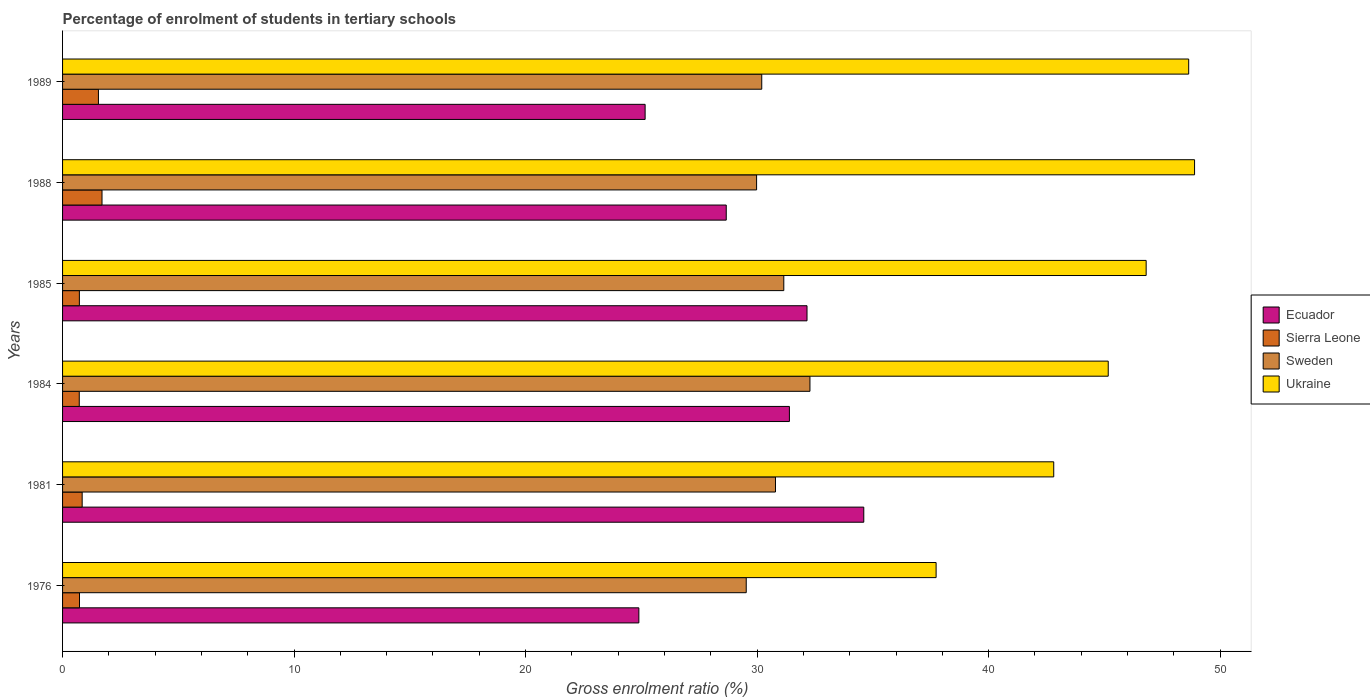How many different coloured bars are there?
Provide a succinct answer. 4. What is the label of the 3rd group of bars from the top?
Your answer should be compact. 1985. What is the percentage of students enrolled in tertiary schools in Sierra Leone in 1985?
Give a very brief answer. 0.73. Across all years, what is the maximum percentage of students enrolled in tertiary schools in Ecuador?
Your answer should be compact. 34.61. Across all years, what is the minimum percentage of students enrolled in tertiary schools in Ukraine?
Give a very brief answer. 37.73. In which year was the percentage of students enrolled in tertiary schools in Sierra Leone maximum?
Provide a succinct answer. 1988. In which year was the percentage of students enrolled in tertiary schools in Ukraine minimum?
Keep it short and to the point. 1976. What is the total percentage of students enrolled in tertiary schools in Ukraine in the graph?
Your answer should be very brief. 270.06. What is the difference between the percentage of students enrolled in tertiary schools in Ukraine in 1981 and that in 1988?
Your answer should be very brief. -6.08. What is the difference between the percentage of students enrolled in tertiary schools in Ukraine in 1985 and the percentage of students enrolled in tertiary schools in Sierra Leone in 1989?
Ensure brevity in your answer.  45.26. What is the average percentage of students enrolled in tertiary schools in Sweden per year?
Your answer should be compact. 30.66. In the year 1976, what is the difference between the percentage of students enrolled in tertiary schools in Ukraine and percentage of students enrolled in tertiary schools in Sierra Leone?
Ensure brevity in your answer.  37. In how many years, is the percentage of students enrolled in tertiary schools in Sierra Leone greater than 18 %?
Provide a succinct answer. 0. What is the ratio of the percentage of students enrolled in tertiary schools in Ukraine in 1976 to that in 1984?
Offer a very short reply. 0.84. What is the difference between the highest and the second highest percentage of students enrolled in tertiary schools in Ecuador?
Provide a short and direct response. 2.45. What is the difference between the highest and the lowest percentage of students enrolled in tertiary schools in Ukraine?
Provide a short and direct response. 11.16. In how many years, is the percentage of students enrolled in tertiary schools in Sierra Leone greater than the average percentage of students enrolled in tertiary schools in Sierra Leone taken over all years?
Provide a short and direct response. 2. Is the sum of the percentage of students enrolled in tertiary schools in Sierra Leone in 1981 and 1984 greater than the maximum percentage of students enrolled in tertiary schools in Sweden across all years?
Offer a very short reply. No. Is it the case that in every year, the sum of the percentage of students enrolled in tertiary schools in Ecuador and percentage of students enrolled in tertiary schools in Sweden is greater than the sum of percentage of students enrolled in tertiary schools in Ukraine and percentage of students enrolled in tertiary schools in Sierra Leone?
Offer a terse response. Yes. What does the 1st bar from the top in 1976 represents?
Offer a terse response. Ukraine. What does the 1st bar from the bottom in 1981 represents?
Ensure brevity in your answer.  Ecuador. How many bars are there?
Make the answer very short. 24. Are the values on the major ticks of X-axis written in scientific E-notation?
Provide a succinct answer. No. Does the graph contain grids?
Your answer should be compact. No. How many legend labels are there?
Provide a succinct answer. 4. What is the title of the graph?
Make the answer very short. Percentage of enrolment of students in tertiary schools. Does "Mauritania" appear as one of the legend labels in the graph?
Provide a short and direct response. No. What is the label or title of the Y-axis?
Offer a terse response. Years. What is the Gross enrolment ratio (%) of Ecuador in 1976?
Ensure brevity in your answer.  24.89. What is the Gross enrolment ratio (%) in Sierra Leone in 1976?
Give a very brief answer. 0.73. What is the Gross enrolment ratio (%) in Sweden in 1976?
Your answer should be very brief. 29.53. What is the Gross enrolment ratio (%) of Ukraine in 1976?
Keep it short and to the point. 37.73. What is the Gross enrolment ratio (%) in Ecuador in 1981?
Offer a very short reply. 34.61. What is the Gross enrolment ratio (%) of Sierra Leone in 1981?
Keep it short and to the point. 0.85. What is the Gross enrolment ratio (%) in Sweden in 1981?
Offer a very short reply. 30.79. What is the Gross enrolment ratio (%) of Ukraine in 1981?
Offer a terse response. 42.81. What is the Gross enrolment ratio (%) in Ecuador in 1984?
Ensure brevity in your answer.  31.4. What is the Gross enrolment ratio (%) of Sierra Leone in 1984?
Keep it short and to the point. 0.72. What is the Gross enrolment ratio (%) in Sweden in 1984?
Your response must be concise. 32.28. What is the Gross enrolment ratio (%) in Ukraine in 1984?
Your answer should be very brief. 45.17. What is the Gross enrolment ratio (%) in Ecuador in 1985?
Provide a short and direct response. 32.16. What is the Gross enrolment ratio (%) of Sierra Leone in 1985?
Provide a short and direct response. 0.73. What is the Gross enrolment ratio (%) in Sweden in 1985?
Your response must be concise. 31.15. What is the Gross enrolment ratio (%) of Ukraine in 1985?
Make the answer very short. 46.8. What is the Gross enrolment ratio (%) in Ecuador in 1988?
Keep it short and to the point. 28.67. What is the Gross enrolment ratio (%) in Sierra Leone in 1988?
Provide a short and direct response. 1.7. What is the Gross enrolment ratio (%) of Sweden in 1988?
Offer a terse response. 29.98. What is the Gross enrolment ratio (%) of Ukraine in 1988?
Provide a short and direct response. 48.9. What is the Gross enrolment ratio (%) of Ecuador in 1989?
Offer a very short reply. 25.16. What is the Gross enrolment ratio (%) of Sierra Leone in 1989?
Your answer should be very brief. 1.55. What is the Gross enrolment ratio (%) in Sweden in 1989?
Your response must be concise. 30.2. What is the Gross enrolment ratio (%) of Ukraine in 1989?
Offer a terse response. 48.64. Across all years, what is the maximum Gross enrolment ratio (%) of Ecuador?
Provide a short and direct response. 34.61. Across all years, what is the maximum Gross enrolment ratio (%) of Sierra Leone?
Your answer should be very brief. 1.7. Across all years, what is the maximum Gross enrolment ratio (%) of Sweden?
Provide a succinct answer. 32.28. Across all years, what is the maximum Gross enrolment ratio (%) in Ukraine?
Your response must be concise. 48.9. Across all years, what is the minimum Gross enrolment ratio (%) in Ecuador?
Your answer should be compact. 24.89. Across all years, what is the minimum Gross enrolment ratio (%) in Sierra Leone?
Make the answer very short. 0.72. Across all years, what is the minimum Gross enrolment ratio (%) of Sweden?
Your answer should be very brief. 29.53. Across all years, what is the minimum Gross enrolment ratio (%) in Ukraine?
Make the answer very short. 37.73. What is the total Gross enrolment ratio (%) in Ecuador in the graph?
Your response must be concise. 176.88. What is the total Gross enrolment ratio (%) of Sierra Leone in the graph?
Offer a very short reply. 6.28. What is the total Gross enrolment ratio (%) of Sweden in the graph?
Your response must be concise. 183.94. What is the total Gross enrolment ratio (%) in Ukraine in the graph?
Your response must be concise. 270.06. What is the difference between the Gross enrolment ratio (%) of Ecuador in 1976 and that in 1981?
Provide a short and direct response. -9.72. What is the difference between the Gross enrolment ratio (%) in Sierra Leone in 1976 and that in 1981?
Make the answer very short. -0.12. What is the difference between the Gross enrolment ratio (%) of Sweden in 1976 and that in 1981?
Keep it short and to the point. -1.26. What is the difference between the Gross enrolment ratio (%) of Ukraine in 1976 and that in 1981?
Ensure brevity in your answer.  -5.08. What is the difference between the Gross enrolment ratio (%) in Ecuador in 1976 and that in 1984?
Your answer should be very brief. -6.5. What is the difference between the Gross enrolment ratio (%) of Sierra Leone in 1976 and that in 1984?
Provide a succinct answer. 0.01. What is the difference between the Gross enrolment ratio (%) in Sweden in 1976 and that in 1984?
Give a very brief answer. -2.75. What is the difference between the Gross enrolment ratio (%) in Ukraine in 1976 and that in 1984?
Give a very brief answer. -7.43. What is the difference between the Gross enrolment ratio (%) of Ecuador in 1976 and that in 1985?
Keep it short and to the point. -7.26. What is the difference between the Gross enrolment ratio (%) in Sierra Leone in 1976 and that in 1985?
Keep it short and to the point. 0.01. What is the difference between the Gross enrolment ratio (%) in Sweden in 1976 and that in 1985?
Provide a succinct answer. -1.62. What is the difference between the Gross enrolment ratio (%) of Ukraine in 1976 and that in 1985?
Your answer should be compact. -9.07. What is the difference between the Gross enrolment ratio (%) of Ecuador in 1976 and that in 1988?
Offer a very short reply. -3.77. What is the difference between the Gross enrolment ratio (%) of Sierra Leone in 1976 and that in 1988?
Give a very brief answer. -0.97. What is the difference between the Gross enrolment ratio (%) in Sweden in 1976 and that in 1988?
Your response must be concise. -0.45. What is the difference between the Gross enrolment ratio (%) of Ukraine in 1976 and that in 1988?
Your response must be concise. -11.16. What is the difference between the Gross enrolment ratio (%) of Ecuador in 1976 and that in 1989?
Ensure brevity in your answer.  -0.27. What is the difference between the Gross enrolment ratio (%) of Sierra Leone in 1976 and that in 1989?
Make the answer very short. -0.82. What is the difference between the Gross enrolment ratio (%) of Sweden in 1976 and that in 1989?
Your answer should be compact. -0.67. What is the difference between the Gross enrolment ratio (%) in Ukraine in 1976 and that in 1989?
Offer a terse response. -10.91. What is the difference between the Gross enrolment ratio (%) of Ecuador in 1981 and that in 1984?
Offer a very short reply. 3.21. What is the difference between the Gross enrolment ratio (%) of Sierra Leone in 1981 and that in 1984?
Give a very brief answer. 0.13. What is the difference between the Gross enrolment ratio (%) in Sweden in 1981 and that in 1984?
Offer a very short reply. -1.49. What is the difference between the Gross enrolment ratio (%) in Ukraine in 1981 and that in 1984?
Provide a succinct answer. -2.35. What is the difference between the Gross enrolment ratio (%) of Ecuador in 1981 and that in 1985?
Your response must be concise. 2.45. What is the difference between the Gross enrolment ratio (%) of Sierra Leone in 1981 and that in 1985?
Offer a very short reply. 0.12. What is the difference between the Gross enrolment ratio (%) in Sweden in 1981 and that in 1985?
Keep it short and to the point. -0.36. What is the difference between the Gross enrolment ratio (%) in Ukraine in 1981 and that in 1985?
Ensure brevity in your answer.  -3.99. What is the difference between the Gross enrolment ratio (%) in Ecuador in 1981 and that in 1988?
Offer a terse response. 5.94. What is the difference between the Gross enrolment ratio (%) in Sierra Leone in 1981 and that in 1988?
Ensure brevity in your answer.  -0.86. What is the difference between the Gross enrolment ratio (%) in Sweden in 1981 and that in 1988?
Your answer should be compact. 0.82. What is the difference between the Gross enrolment ratio (%) in Ukraine in 1981 and that in 1988?
Provide a succinct answer. -6.08. What is the difference between the Gross enrolment ratio (%) in Ecuador in 1981 and that in 1989?
Your answer should be compact. 9.45. What is the difference between the Gross enrolment ratio (%) in Sierra Leone in 1981 and that in 1989?
Offer a very short reply. -0.7. What is the difference between the Gross enrolment ratio (%) in Sweden in 1981 and that in 1989?
Your answer should be very brief. 0.59. What is the difference between the Gross enrolment ratio (%) of Ukraine in 1981 and that in 1989?
Offer a terse response. -5.83. What is the difference between the Gross enrolment ratio (%) in Ecuador in 1984 and that in 1985?
Your response must be concise. -0.76. What is the difference between the Gross enrolment ratio (%) of Sierra Leone in 1984 and that in 1985?
Provide a short and direct response. -0. What is the difference between the Gross enrolment ratio (%) of Sweden in 1984 and that in 1985?
Offer a terse response. 1.13. What is the difference between the Gross enrolment ratio (%) of Ukraine in 1984 and that in 1985?
Make the answer very short. -1.64. What is the difference between the Gross enrolment ratio (%) in Ecuador in 1984 and that in 1988?
Offer a terse response. 2.73. What is the difference between the Gross enrolment ratio (%) in Sierra Leone in 1984 and that in 1988?
Your response must be concise. -0.98. What is the difference between the Gross enrolment ratio (%) of Sweden in 1984 and that in 1988?
Provide a succinct answer. 2.3. What is the difference between the Gross enrolment ratio (%) in Ukraine in 1984 and that in 1988?
Give a very brief answer. -3.73. What is the difference between the Gross enrolment ratio (%) in Ecuador in 1984 and that in 1989?
Provide a succinct answer. 6.23. What is the difference between the Gross enrolment ratio (%) of Sierra Leone in 1984 and that in 1989?
Your answer should be very brief. -0.83. What is the difference between the Gross enrolment ratio (%) in Sweden in 1984 and that in 1989?
Keep it short and to the point. 2.08. What is the difference between the Gross enrolment ratio (%) in Ukraine in 1984 and that in 1989?
Provide a succinct answer. -3.48. What is the difference between the Gross enrolment ratio (%) in Ecuador in 1985 and that in 1988?
Provide a succinct answer. 3.49. What is the difference between the Gross enrolment ratio (%) of Sierra Leone in 1985 and that in 1988?
Keep it short and to the point. -0.98. What is the difference between the Gross enrolment ratio (%) in Sweden in 1985 and that in 1988?
Make the answer very short. 1.18. What is the difference between the Gross enrolment ratio (%) in Ukraine in 1985 and that in 1988?
Provide a short and direct response. -2.09. What is the difference between the Gross enrolment ratio (%) in Ecuador in 1985 and that in 1989?
Ensure brevity in your answer.  6.99. What is the difference between the Gross enrolment ratio (%) in Sierra Leone in 1985 and that in 1989?
Keep it short and to the point. -0.82. What is the difference between the Gross enrolment ratio (%) in Sweden in 1985 and that in 1989?
Offer a very short reply. 0.95. What is the difference between the Gross enrolment ratio (%) in Ukraine in 1985 and that in 1989?
Your response must be concise. -1.84. What is the difference between the Gross enrolment ratio (%) of Ecuador in 1988 and that in 1989?
Give a very brief answer. 3.5. What is the difference between the Gross enrolment ratio (%) in Sierra Leone in 1988 and that in 1989?
Give a very brief answer. 0.15. What is the difference between the Gross enrolment ratio (%) of Sweden in 1988 and that in 1989?
Give a very brief answer. -0.22. What is the difference between the Gross enrolment ratio (%) in Ukraine in 1988 and that in 1989?
Ensure brevity in your answer.  0.25. What is the difference between the Gross enrolment ratio (%) of Ecuador in 1976 and the Gross enrolment ratio (%) of Sierra Leone in 1981?
Give a very brief answer. 24.05. What is the difference between the Gross enrolment ratio (%) of Ecuador in 1976 and the Gross enrolment ratio (%) of Sweden in 1981?
Your answer should be compact. -5.9. What is the difference between the Gross enrolment ratio (%) of Ecuador in 1976 and the Gross enrolment ratio (%) of Ukraine in 1981?
Keep it short and to the point. -17.92. What is the difference between the Gross enrolment ratio (%) of Sierra Leone in 1976 and the Gross enrolment ratio (%) of Sweden in 1981?
Your answer should be very brief. -30.06. What is the difference between the Gross enrolment ratio (%) in Sierra Leone in 1976 and the Gross enrolment ratio (%) in Ukraine in 1981?
Ensure brevity in your answer.  -42.08. What is the difference between the Gross enrolment ratio (%) of Sweden in 1976 and the Gross enrolment ratio (%) of Ukraine in 1981?
Provide a succinct answer. -13.28. What is the difference between the Gross enrolment ratio (%) in Ecuador in 1976 and the Gross enrolment ratio (%) in Sierra Leone in 1984?
Your response must be concise. 24.17. What is the difference between the Gross enrolment ratio (%) in Ecuador in 1976 and the Gross enrolment ratio (%) in Sweden in 1984?
Keep it short and to the point. -7.39. What is the difference between the Gross enrolment ratio (%) of Ecuador in 1976 and the Gross enrolment ratio (%) of Ukraine in 1984?
Your answer should be compact. -20.27. What is the difference between the Gross enrolment ratio (%) in Sierra Leone in 1976 and the Gross enrolment ratio (%) in Sweden in 1984?
Provide a succinct answer. -31.55. What is the difference between the Gross enrolment ratio (%) in Sierra Leone in 1976 and the Gross enrolment ratio (%) in Ukraine in 1984?
Your answer should be compact. -44.44. What is the difference between the Gross enrolment ratio (%) of Sweden in 1976 and the Gross enrolment ratio (%) of Ukraine in 1984?
Your answer should be compact. -15.64. What is the difference between the Gross enrolment ratio (%) of Ecuador in 1976 and the Gross enrolment ratio (%) of Sierra Leone in 1985?
Provide a short and direct response. 24.17. What is the difference between the Gross enrolment ratio (%) of Ecuador in 1976 and the Gross enrolment ratio (%) of Sweden in 1985?
Provide a succinct answer. -6.26. What is the difference between the Gross enrolment ratio (%) in Ecuador in 1976 and the Gross enrolment ratio (%) in Ukraine in 1985?
Your response must be concise. -21.91. What is the difference between the Gross enrolment ratio (%) in Sierra Leone in 1976 and the Gross enrolment ratio (%) in Sweden in 1985?
Provide a short and direct response. -30.42. What is the difference between the Gross enrolment ratio (%) of Sierra Leone in 1976 and the Gross enrolment ratio (%) of Ukraine in 1985?
Keep it short and to the point. -46.07. What is the difference between the Gross enrolment ratio (%) of Sweden in 1976 and the Gross enrolment ratio (%) of Ukraine in 1985?
Provide a succinct answer. -17.27. What is the difference between the Gross enrolment ratio (%) of Ecuador in 1976 and the Gross enrolment ratio (%) of Sierra Leone in 1988?
Make the answer very short. 23.19. What is the difference between the Gross enrolment ratio (%) of Ecuador in 1976 and the Gross enrolment ratio (%) of Sweden in 1988?
Your answer should be compact. -5.09. What is the difference between the Gross enrolment ratio (%) in Ecuador in 1976 and the Gross enrolment ratio (%) in Ukraine in 1988?
Offer a very short reply. -24. What is the difference between the Gross enrolment ratio (%) of Sierra Leone in 1976 and the Gross enrolment ratio (%) of Sweden in 1988?
Keep it short and to the point. -29.25. What is the difference between the Gross enrolment ratio (%) in Sierra Leone in 1976 and the Gross enrolment ratio (%) in Ukraine in 1988?
Ensure brevity in your answer.  -48.16. What is the difference between the Gross enrolment ratio (%) of Sweden in 1976 and the Gross enrolment ratio (%) of Ukraine in 1988?
Give a very brief answer. -19.37. What is the difference between the Gross enrolment ratio (%) in Ecuador in 1976 and the Gross enrolment ratio (%) in Sierra Leone in 1989?
Give a very brief answer. 23.34. What is the difference between the Gross enrolment ratio (%) of Ecuador in 1976 and the Gross enrolment ratio (%) of Sweden in 1989?
Your answer should be compact. -5.31. What is the difference between the Gross enrolment ratio (%) in Ecuador in 1976 and the Gross enrolment ratio (%) in Ukraine in 1989?
Keep it short and to the point. -23.75. What is the difference between the Gross enrolment ratio (%) in Sierra Leone in 1976 and the Gross enrolment ratio (%) in Sweden in 1989?
Provide a succinct answer. -29.47. What is the difference between the Gross enrolment ratio (%) in Sierra Leone in 1976 and the Gross enrolment ratio (%) in Ukraine in 1989?
Offer a terse response. -47.91. What is the difference between the Gross enrolment ratio (%) of Sweden in 1976 and the Gross enrolment ratio (%) of Ukraine in 1989?
Your answer should be very brief. -19.11. What is the difference between the Gross enrolment ratio (%) of Ecuador in 1981 and the Gross enrolment ratio (%) of Sierra Leone in 1984?
Your answer should be compact. 33.89. What is the difference between the Gross enrolment ratio (%) of Ecuador in 1981 and the Gross enrolment ratio (%) of Sweden in 1984?
Your answer should be very brief. 2.33. What is the difference between the Gross enrolment ratio (%) in Ecuador in 1981 and the Gross enrolment ratio (%) in Ukraine in 1984?
Your answer should be compact. -10.56. What is the difference between the Gross enrolment ratio (%) of Sierra Leone in 1981 and the Gross enrolment ratio (%) of Sweden in 1984?
Keep it short and to the point. -31.44. What is the difference between the Gross enrolment ratio (%) of Sierra Leone in 1981 and the Gross enrolment ratio (%) of Ukraine in 1984?
Give a very brief answer. -44.32. What is the difference between the Gross enrolment ratio (%) of Sweden in 1981 and the Gross enrolment ratio (%) of Ukraine in 1984?
Make the answer very short. -14.37. What is the difference between the Gross enrolment ratio (%) in Ecuador in 1981 and the Gross enrolment ratio (%) in Sierra Leone in 1985?
Your response must be concise. 33.88. What is the difference between the Gross enrolment ratio (%) of Ecuador in 1981 and the Gross enrolment ratio (%) of Sweden in 1985?
Keep it short and to the point. 3.45. What is the difference between the Gross enrolment ratio (%) of Ecuador in 1981 and the Gross enrolment ratio (%) of Ukraine in 1985?
Offer a terse response. -12.2. What is the difference between the Gross enrolment ratio (%) of Sierra Leone in 1981 and the Gross enrolment ratio (%) of Sweden in 1985?
Make the answer very short. -30.31. What is the difference between the Gross enrolment ratio (%) of Sierra Leone in 1981 and the Gross enrolment ratio (%) of Ukraine in 1985?
Your answer should be very brief. -45.96. What is the difference between the Gross enrolment ratio (%) of Sweden in 1981 and the Gross enrolment ratio (%) of Ukraine in 1985?
Your answer should be very brief. -16.01. What is the difference between the Gross enrolment ratio (%) of Ecuador in 1981 and the Gross enrolment ratio (%) of Sierra Leone in 1988?
Offer a very short reply. 32.9. What is the difference between the Gross enrolment ratio (%) of Ecuador in 1981 and the Gross enrolment ratio (%) of Sweden in 1988?
Offer a very short reply. 4.63. What is the difference between the Gross enrolment ratio (%) in Ecuador in 1981 and the Gross enrolment ratio (%) in Ukraine in 1988?
Provide a succinct answer. -14.29. What is the difference between the Gross enrolment ratio (%) in Sierra Leone in 1981 and the Gross enrolment ratio (%) in Sweden in 1988?
Offer a terse response. -29.13. What is the difference between the Gross enrolment ratio (%) in Sierra Leone in 1981 and the Gross enrolment ratio (%) in Ukraine in 1988?
Ensure brevity in your answer.  -48.05. What is the difference between the Gross enrolment ratio (%) of Sweden in 1981 and the Gross enrolment ratio (%) of Ukraine in 1988?
Give a very brief answer. -18.1. What is the difference between the Gross enrolment ratio (%) of Ecuador in 1981 and the Gross enrolment ratio (%) of Sierra Leone in 1989?
Keep it short and to the point. 33.06. What is the difference between the Gross enrolment ratio (%) of Ecuador in 1981 and the Gross enrolment ratio (%) of Sweden in 1989?
Provide a short and direct response. 4.41. What is the difference between the Gross enrolment ratio (%) of Ecuador in 1981 and the Gross enrolment ratio (%) of Ukraine in 1989?
Your answer should be very brief. -14.03. What is the difference between the Gross enrolment ratio (%) of Sierra Leone in 1981 and the Gross enrolment ratio (%) of Sweden in 1989?
Ensure brevity in your answer.  -29.35. What is the difference between the Gross enrolment ratio (%) in Sierra Leone in 1981 and the Gross enrolment ratio (%) in Ukraine in 1989?
Keep it short and to the point. -47.8. What is the difference between the Gross enrolment ratio (%) in Sweden in 1981 and the Gross enrolment ratio (%) in Ukraine in 1989?
Offer a terse response. -17.85. What is the difference between the Gross enrolment ratio (%) of Ecuador in 1984 and the Gross enrolment ratio (%) of Sierra Leone in 1985?
Offer a terse response. 30.67. What is the difference between the Gross enrolment ratio (%) of Ecuador in 1984 and the Gross enrolment ratio (%) of Sweden in 1985?
Give a very brief answer. 0.24. What is the difference between the Gross enrolment ratio (%) in Ecuador in 1984 and the Gross enrolment ratio (%) in Ukraine in 1985?
Ensure brevity in your answer.  -15.41. What is the difference between the Gross enrolment ratio (%) in Sierra Leone in 1984 and the Gross enrolment ratio (%) in Sweden in 1985?
Your answer should be very brief. -30.43. What is the difference between the Gross enrolment ratio (%) of Sierra Leone in 1984 and the Gross enrolment ratio (%) of Ukraine in 1985?
Your response must be concise. -46.08. What is the difference between the Gross enrolment ratio (%) in Sweden in 1984 and the Gross enrolment ratio (%) in Ukraine in 1985?
Give a very brief answer. -14.52. What is the difference between the Gross enrolment ratio (%) of Ecuador in 1984 and the Gross enrolment ratio (%) of Sierra Leone in 1988?
Your answer should be very brief. 29.69. What is the difference between the Gross enrolment ratio (%) of Ecuador in 1984 and the Gross enrolment ratio (%) of Sweden in 1988?
Make the answer very short. 1.42. What is the difference between the Gross enrolment ratio (%) in Ecuador in 1984 and the Gross enrolment ratio (%) in Ukraine in 1988?
Provide a succinct answer. -17.5. What is the difference between the Gross enrolment ratio (%) of Sierra Leone in 1984 and the Gross enrolment ratio (%) of Sweden in 1988?
Offer a very short reply. -29.26. What is the difference between the Gross enrolment ratio (%) in Sierra Leone in 1984 and the Gross enrolment ratio (%) in Ukraine in 1988?
Your response must be concise. -48.17. What is the difference between the Gross enrolment ratio (%) in Sweden in 1984 and the Gross enrolment ratio (%) in Ukraine in 1988?
Give a very brief answer. -16.61. What is the difference between the Gross enrolment ratio (%) of Ecuador in 1984 and the Gross enrolment ratio (%) of Sierra Leone in 1989?
Your answer should be very brief. 29.85. What is the difference between the Gross enrolment ratio (%) in Ecuador in 1984 and the Gross enrolment ratio (%) in Sweden in 1989?
Make the answer very short. 1.19. What is the difference between the Gross enrolment ratio (%) of Ecuador in 1984 and the Gross enrolment ratio (%) of Ukraine in 1989?
Make the answer very short. -17.25. What is the difference between the Gross enrolment ratio (%) in Sierra Leone in 1984 and the Gross enrolment ratio (%) in Sweden in 1989?
Offer a very short reply. -29.48. What is the difference between the Gross enrolment ratio (%) of Sierra Leone in 1984 and the Gross enrolment ratio (%) of Ukraine in 1989?
Ensure brevity in your answer.  -47.92. What is the difference between the Gross enrolment ratio (%) of Sweden in 1984 and the Gross enrolment ratio (%) of Ukraine in 1989?
Your response must be concise. -16.36. What is the difference between the Gross enrolment ratio (%) in Ecuador in 1985 and the Gross enrolment ratio (%) in Sierra Leone in 1988?
Provide a short and direct response. 30.45. What is the difference between the Gross enrolment ratio (%) of Ecuador in 1985 and the Gross enrolment ratio (%) of Sweden in 1988?
Offer a terse response. 2.18. What is the difference between the Gross enrolment ratio (%) in Ecuador in 1985 and the Gross enrolment ratio (%) in Ukraine in 1988?
Offer a very short reply. -16.74. What is the difference between the Gross enrolment ratio (%) in Sierra Leone in 1985 and the Gross enrolment ratio (%) in Sweden in 1988?
Provide a short and direct response. -29.25. What is the difference between the Gross enrolment ratio (%) of Sierra Leone in 1985 and the Gross enrolment ratio (%) of Ukraine in 1988?
Your answer should be compact. -48.17. What is the difference between the Gross enrolment ratio (%) of Sweden in 1985 and the Gross enrolment ratio (%) of Ukraine in 1988?
Your answer should be very brief. -17.74. What is the difference between the Gross enrolment ratio (%) of Ecuador in 1985 and the Gross enrolment ratio (%) of Sierra Leone in 1989?
Your answer should be compact. 30.61. What is the difference between the Gross enrolment ratio (%) of Ecuador in 1985 and the Gross enrolment ratio (%) of Sweden in 1989?
Your answer should be compact. 1.96. What is the difference between the Gross enrolment ratio (%) of Ecuador in 1985 and the Gross enrolment ratio (%) of Ukraine in 1989?
Ensure brevity in your answer.  -16.49. What is the difference between the Gross enrolment ratio (%) of Sierra Leone in 1985 and the Gross enrolment ratio (%) of Sweden in 1989?
Offer a very short reply. -29.47. What is the difference between the Gross enrolment ratio (%) in Sierra Leone in 1985 and the Gross enrolment ratio (%) in Ukraine in 1989?
Give a very brief answer. -47.92. What is the difference between the Gross enrolment ratio (%) of Sweden in 1985 and the Gross enrolment ratio (%) of Ukraine in 1989?
Provide a short and direct response. -17.49. What is the difference between the Gross enrolment ratio (%) in Ecuador in 1988 and the Gross enrolment ratio (%) in Sierra Leone in 1989?
Give a very brief answer. 27.12. What is the difference between the Gross enrolment ratio (%) of Ecuador in 1988 and the Gross enrolment ratio (%) of Sweden in 1989?
Your response must be concise. -1.53. What is the difference between the Gross enrolment ratio (%) in Ecuador in 1988 and the Gross enrolment ratio (%) in Ukraine in 1989?
Ensure brevity in your answer.  -19.97. What is the difference between the Gross enrolment ratio (%) of Sierra Leone in 1988 and the Gross enrolment ratio (%) of Sweden in 1989?
Keep it short and to the point. -28.5. What is the difference between the Gross enrolment ratio (%) of Sierra Leone in 1988 and the Gross enrolment ratio (%) of Ukraine in 1989?
Ensure brevity in your answer.  -46.94. What is the difference between the Gross enrolment ratio (%) in Sweden in 1988 and the Gross enrolment ratio (%) in Ukraine in 1989?
Ensure brevity in your answer.  -18.66. What is the average Gross enrolment ratio (%) of Ecuador per year?
Offer a very short reply. 29.48. What is the average Gross enrolment ratio (%) of Sierra Leone per year?
Your answer should be very brief. 1.05. What is the average Gross enrolment ratio (%) in Sweden per year?
Keep it short and to the point. 30.66. What is the average Gross enrolment ratio (%) in Ukraine per year?
Provide a succinct answer. 45.01. In the year 1976, what is the difference between the Gross enrolment ratio (%) of Ecuador and Gross enrolment ratio (%) of Sierra Leone?
Provide a short and direct response. 24.16. In the year 1976, what is the difference between the Gross enrolment ratio (%) of Ecuador and Gross enrolment ratio (%) of Sweden?
Offer a very short reply. -4.64. In the year 1976, what is the difference between the Gross enrolment ratio (%) in Ecuador and Gross enrolment ratio (%) in Ukraine?
Give a very brief answer. -12.84. In the year 1976, what is the difference between the Gross enrolment ratio (%) in Sierra Leone and Gross enrolment ratio (%) in Sweden?
Offer a very short reply. -28.8. In the year 1976, what is the difference between the Gross enrolment ratio (%) of Sierra Leone and Gross enrolment ratio (%) of Ukraine?
Ensure brevity in your answer.  -37. In the year 1976, what is the difference between the Gross enrolment ratio (%) in Sweden and Gross enrolment ratio (%) in Ukraine?
Keep it short and to the point. -8.2. In the year 1981, what is the difference between the Gross enrolment ratio (%) in Ecuador and Gross enrolment ratio (%) in Sierra Leone?
Keep it short and to the point. 33.76. In the year 1981, what is the difference between the Gross enrolment ratio (%) in Ecuador and Gross enrolment ratio (%) in Sweden?
Provide a succinct answer. 3.81. In the year 1981, what is the difference between the Gross enrolment ratio (%) in Ecuador and Gross enrolment ratio (%) in Ukraine?
Your answer should be very brief. -8.2. In the year 1981, what is the difference between the Gross enrolment ratio (%) in Sierra Leone and Gross enrolment ratio (%) in Sweden?
Provide a succinct answer. -29.95. In the year 1981, what is the difference between the Gross enrolment ratio (%) in Sierra Leone and Gross enrolment ratio (%) in Ukraine?
Your answer should be compact. -41.97. In the year 1981, what is the difference between the Gross enrolment ratio (%) in Sweden and Gross enrolment ratio (%) in Ukraine?
Provide a succinct answer. -12.02. In the year 1984, what is the difference between the Gross enrolment ratio (%) of Ecuador and Gross enrolment ratio (%) of Sierra Leone?
Ensure brevity in your answer.  30.67. In the year 1984, what is the difference between the Gross enrolment ratio (%) in Ecuador and Gross enrolment ratio (%) in Sweden?
Your response must be concise. -0.89. In the year 1984, what is the difference between the Gross enrolment ratio (%) in Ecuador and Gross enrolment ratio (%) in Ukraine?
Ensure brevity in your answer.  -13.77. In the year 1984, what is the difference between the Gross enrolment ratio (%) of Sierra Leone and Gross enrolment ratio (%) of Sweden?
Make the answer very short. -31.56. In the year 1984, what is the difference between the Gross enrolment ratio (%) of Sierra Leone and Gross enrolment ratio (%) of Ukraine?
Provide a short and direct response. -44.45. In the year 1984, what is the difference between the Gross enrolment ratio (%) of Sweden and Gross enrolment ratio (%) of Ukraine?
Offer a very short reply. -12.88. In the year 1985, what is the difference between the Gross enrolment ratio (%) of Ecuador and Gross enrolment ratio (%) of Sierra Leone?
Give a very brief answer. 31.43. In the year 1985, what is the difference between the Gross enrolment ratio (%) of Ecuador and Gross enrolment ratio (%) of Sweden?
Provide a succinct answer. 1. In the year 1985, what is the difference between the Gross enrolment ratio (%) in Ecuador and Gross enrolment ratio (%) in Ukraine?
Make the answer very short. -14.65. In the year 1985, what is the difference between the Gross enrolment ratio (%) in Sierra Leone and Gross enrolment ratio (%) in Sweden?
Make the answer very short. -30.43. In the year 1985, what is the difference between the Gross enrolment ratio (%) in Sierra Leone and Gross enrolment ratio (%) in Ukraine?
Ensure brevity in your answer.  -46.08. In the year 1985, what is the difference between the Gross enrolment ratio (%) of Sweden and Gross enrolment ratio (%) of Ukraine?
Keep it short and to the point. -15.65. In the year 1988, what is the difference between the Gross enrolment ratio (%) in Ecuador and Gross enrolment ratio (%) in Sierra Leone?
Keep it short and to the point. 26.96. In the year 1988, what is the difference between the Gross enrolment ratio (%) of Ecuador and Gross enrolment ratio (%) of Sweden?
Ensure brevity in your answer.  -1.31. In the year 1988, what is the difference between the Gross enrolment ratio (%) in Ecuador and Gross enrolment ratio (%) in Ukraine?
Make the answer very short. -20.23. In the year 1988, what is the difference between the Gross enrolment ratio (%) of Sierra Leone and Gross enrolment ratio (%) of Sweden?
Your answer should be very brief. -28.27. In the year 1988, what is the difference between the Gross enrolment ratio (%) of Sierra Leone and Gross enrolment ratio (%) of Ukraine?
Your response must be concise. -47.19. In the year 1988, what is the difference between the Gross enrolment ratio (%) of Sweden and Gross enrolment ratio (%) of Ukraine?
Make the answer very short. -18.92. In the year 1989, what is the difference between the Gross enrolment ratio (%) of Ecuador and Gross enrolment ratio (%) of Sierra Leone?
Provide a short and direct response. 23.61. In the year 1989, what is the difference between the Gross enrolment ratio (%) of Ecuador and Gross enrolment ratio (%) of Sweden?
Ensure brevity in your answer.  -5.04. In the year 1989, what is the difference between the Gross enrolment ratio (%) of Ecuador and Gross enrolment ratio (%) of Ukraine?
Give a very brief answer. -23.48. In the year 1989, what is the difference between the Gross enrolment ratio (%) of Sierra Leone and Gross enrolment ratio (%) of Sweden?
Ensure brevity in your answer.  -28.65. In the year 1989, what is the difference between the Gross enrolment ratio (%) in Sierra Leone and Gross enrolment ratio (%) in Ukraine?
Ensure brevity in your answer.  -47.09. In the year 1989, what is the difference between the Gross enrolment ratio (%) in Sweden and Gross enrolment ratio (%) in Ukraine?
Provide a short and direct response. -18.44. What is the ratio of the Gross enrolment ratio (%) in Ecuador in 1976 to that in 1981?
Your answer should be compact. 0.72. What is the ratio of the Gross enrolment ratio (%) of Sierra Leone in 1976 to that in 1981?
Provide a short and direct response. 0.86. What is the ratio of the Gross enrolment ratio (%) in Ukraine in 1976 to that in 1981?
Ensure brevity in your answer.  0.88. What is the ratio of the Gross enrolment ratio (%) in Ecuador in 1976 to that in 1984?
Ensure brevity in your answer.  0.79. What is the ratio of the Gross enrolment ratio (%) of Sweden in 1976 to that in 1984?
Keep it short and to the point. 0.91. What is the ratio of the Gross enrolment ratio (%) in Ukraine in 1976 to that in 1984?
Offer a terse response. 0.84. What is the ratio of the Gross enrolment ratio (%) of Ecuador in 1976 to that in 1985?
Provide a short and direct response. 0.77. What is the ratio of the Gross enrolment ratio (%) in Sweden in 1976 to that in 1985?
Make the answer very short. 0.95. What is the ratio of the Gross enrolment ratio (%) in Ukraine in 1976 to that in 1985?
Your answer should be compact. 0.81. What is the ratio of the Gross enrolment ratio (%) in Ecuador in 1976 to that in 1988?
Provide a short and direct response. 0.87. What is the ratio of the Gross enrolment ratio (%) of Sierra Leone in 1976 to that in 1988?
Offer a terse response. 0.43. What is the ratio of the Gross enrolment ratio (%) in Sweden in 1976 to that in 1988?
Provide a succinct answer. 0.99. What is the ratio of the Gross enrolment ratio (%) in Ukraine in 1976 to that in 1988?
Offer a very short reply. 0.77. What is the ratio of the Gross enrolment ratio (%) of Ecuador in 1976 to that in 1989?
Your response must be concise. 0.99. What is the ratio of the Gross enrolment ratio (%) in Sierra Leone in 1976 to that in 1989?
Your answer should be compact. 0.47. What is the ratio of the Gross enrolment ratio (%) of Sweden in 1976 to that in 1989?
Offer a very short reply. 0.98. What is the ratio of the Gross enrolment ratio (%) in Ukraine in 1976 to that in 1989?
Keep it short and to the point. 0.78. What is the ratio of the Gross enrolment ratio (%) in Ecuador in 1981 to that in 1984?
Your answer should be very brief. 1.1. What is the ratio of the Gross enrolment ratio (%) of Sierra Leone in 1981 to that in 1984?
Provide a short and direct response. 1.17. What is the ratio of the Gross enrolment ratio (%) in Sweden in 1981 to that in 1984?
Give a very brief answer. 0.95. What is the ratio of the Gross enrolment ratio (%) of Ukraine in 1981 to that in 1984?
Make the answer very short. 0.95. What is the ratio of the Gross enrolment ratio (%) of Ecuador in 1981 to that in 1985?
Your response must be concise. 1.08. What is the ratio of the Gross enrolment ratio (%) of Sierra Leone in 1981 to that in 1985?
Give a very brief answer. 1.17. What is the ratio of the Gross enrolment ratio (%) of Sweden in 1981 to that in 1985?
Ensure brevity in your answer.  0.99. What is the ratio of the Gross enrolment ratio (%) in Ukraine in 1981 to that in 1985?
Your answer should be very brief. 0.91. What is the ratio of the Gross enrolment ratio (%) of Ecuador in 1981 to that in 1988?
Your answer should be very brief. 1.21. What is the ratio of the Gross enrolment ratio (%) in Sierra Leone in 1981 to that in 1988?
Your answer should be very brief. 0.5. What is the ratio of the Gross enrolment ratio (%) in Sweden in 1981 to that in 1988?
Give a very brief answer. 1.03. What is the ratio of the Gross enrolment ratio (%) of Ukraine in 1981 to that in 1988?
Give a very brief answer. 0.88. What is the ratio of the Gross enrolment ratio (%) of Ecuador in 1981 to that in 1989?
Ensure brevity in your answer.  1.38. What is the ratio of the Gross enrolment ratio (%) of Sierra Leone in 1981 to that in 1989?
Give a very brief answer. 0.55. What is the ratio of the Gross enrolment ratio (%) of Sweden in 1981 to that in 1989?
Provide a short and direct response. 1.02. What is the ratio of the Gross enrolment ratio (%) of Ukraine in 1981 to that in 1989?
Your answer should be compact. 0.88. What is the ratio of the Gross enrolment ratio (%) of Ecuador in 1984 to that in 1985?
Make the answer very short. 0.98. What is the ratio of the Gross enrolment ratio (%) in Sweden in 1984 to that in 1985?
Your response must be concise. 1.04. What is the ratio of the Gross enrolment ratio (%) of Ecuador in 1984 to that in 1988?
Keep it short and to the point. 1.1. What is the ratio of the Gross enrolment ratio (%) of Sierra Leone in 1984 to that in 1988?
Offer a terse response. 0.42. What is the ratio of the Gross enrolment ratio (%) in Ukraine in 1984 to that in 1988?
Ensure brevity in your answer.  0.92. What is the ratio of the Gross enrolment ratio (%) of Ecuador in 1984 to that in 1989?
Offer a very short reply. 1.25. What is the ratio of the Gross enrolment ratio (%) of Sierra Leone in 1984 to that in 1989?
Offer a terse response. 0.47. What is the ratio of the Gross enrolment ratio (%) in Sweden in 1984 to that in 1989?
Offer a terse response. 1.07. What is the ratio of the Gross enrolment ratio (%) in Ecuador in 1985 to that in 1988?
Provide a short and direct response. 1.12. What is the ratio of the Gross enrolment ratio (%) in Sierra Leone in 1985 to that in 1988?
Your answer should be compact. 0.43. What is the ratio of the Gross enrolment ratio (%) of Sweden in 1985 to that in 1988?
Give a very brief answer. 1.04. What is the ratio of the Gross enrolment ratio (%) in Ukraine in 1985 to that in 1988?
Give a very brief answer. 0.96. What is the ratio of the Gross enrolment ratio (%) of Ecuador in 1985 to that in 1989?
Your answer should be compact. 1.28. What is the ratio of the Gross enrolment ratio (%) in Sierra Leone in 1985 to that in 1989?
Offer a terse response. 0.47. What is the ratio of the Gross enrolment ratio (%) in Sweden in 1985 to that in 1989?
Your answer should be very brief. 1.03. What is the ratio of the Gross enrolment ratio (%) in Ukraine in 1985 to that in 1989?
Provide a succinct answer. 0.96. What is the ratio of the Gross enrolment ratio (%) in Ecuador in 1988 to that in 1989?
Your answer should be very brief. 1.14. What is the ratio of the Gross enrolment ratio (%) of Sierra Leone in 1988 to that in 1989?
Keep it short and to the point. 1.1. What is the ratio of the Gross enrolment ratio (%) of Ukraine in 1988 to that in 1989?
Keep it short and to the point. 1.01. What is the difference between the highest and the second highest Gross enrolment ratio (%) in Ecuador?
Keep it short and to the point. 2.45. What is the difference between the highest and the second highest Gross enrolment ratio (%) in Sierra Leone?
Your answer should be compact. 0.15. What is the difference between the highest and the second highest Gross enrolment ratio (%) of Sweden?
Ensure brevity in your answer.  1.13. What is the difference between the highest and the second highest Gross enrolment ratio (%) of Ukraine?
Ensure brevity in your answer.  0.25. What is the difference between the highest and the lowest Gross enrolment ratio (%) in Ecuador?
Offer a terse response. 9.72. What is the difference between the highest and the lowest Gross enrolment ratio (%) in Sierra Leone?
Make the answer very short. 0.98. What is the difference between the highest and the lowest Gross enrolment ratio (%) of Sweden?
Give a very brief answer. 2.75. What is the difference between the highest and the lowest Gross enrolment ratio (%) of Ukraine?
Offer a very short reply. 11.16. 